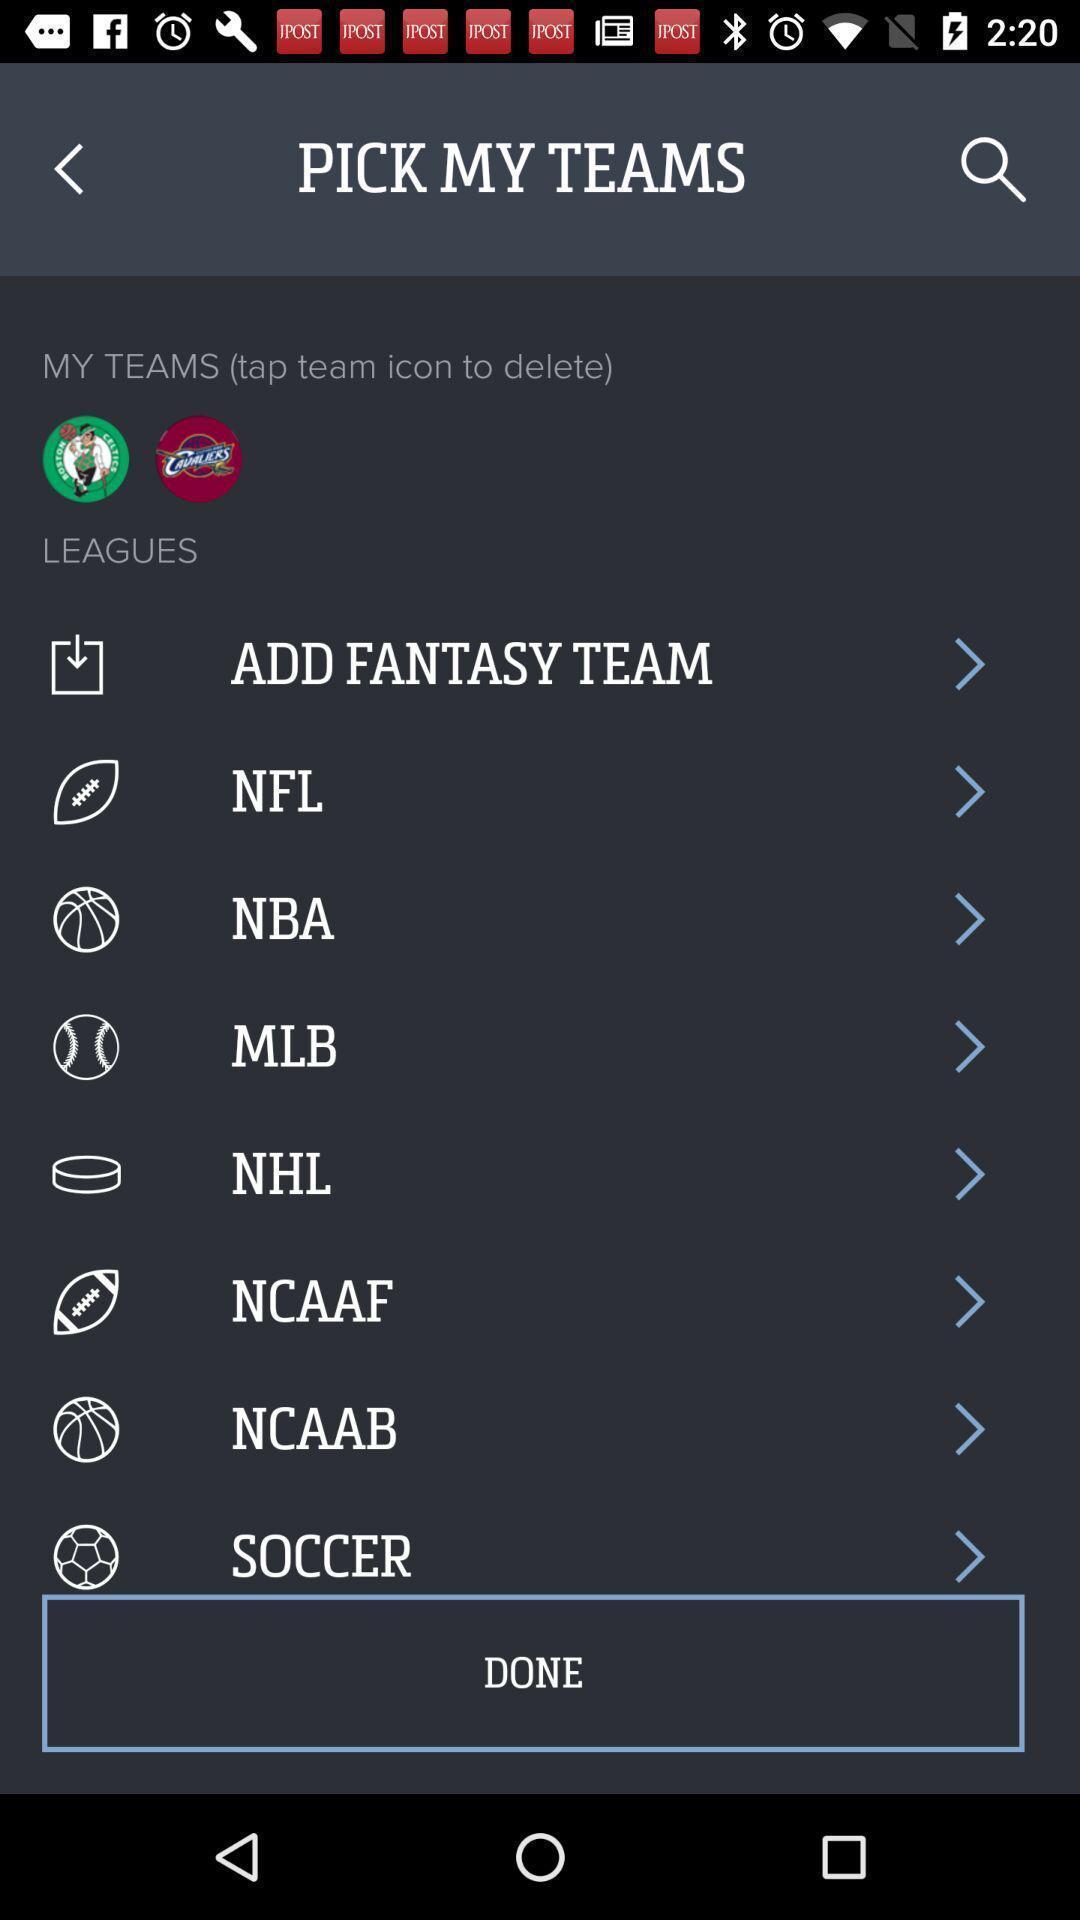Give me a narrative description of this picture. Screen displaying the list of sports. 